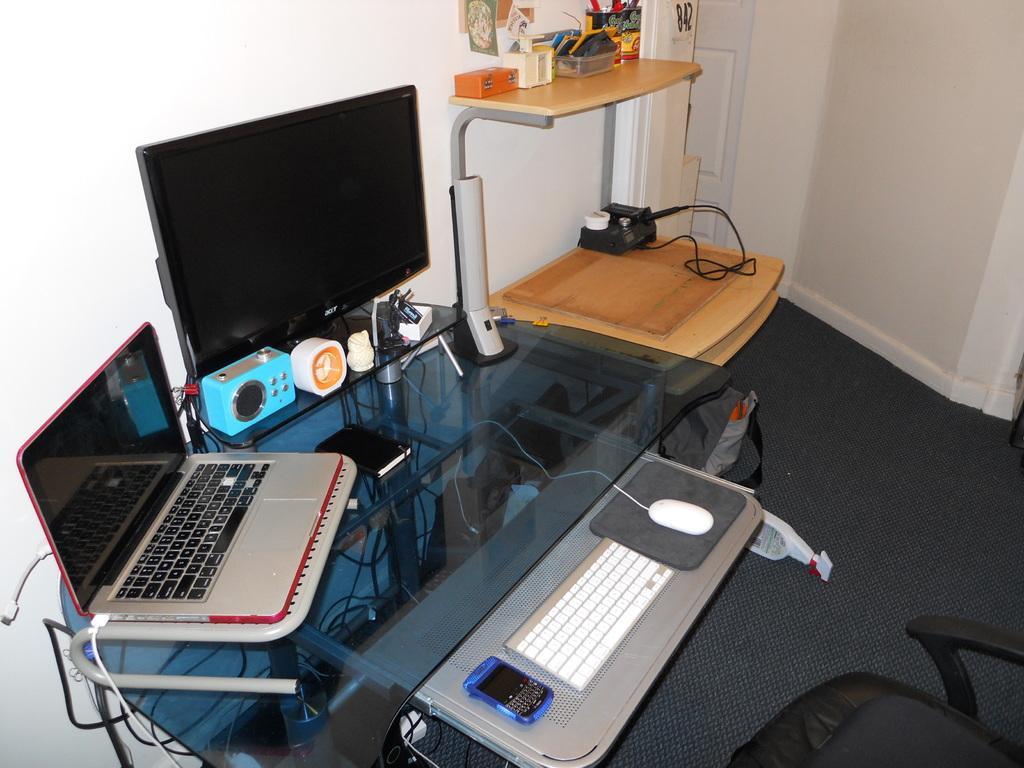Could you give a brief overview of what you see in this image? In this image there are monitors, keyboard, mobile, mouse which are kept on the table. At the right side there is a black colour chair. In the center there are wires. And in the background there is a wall. 